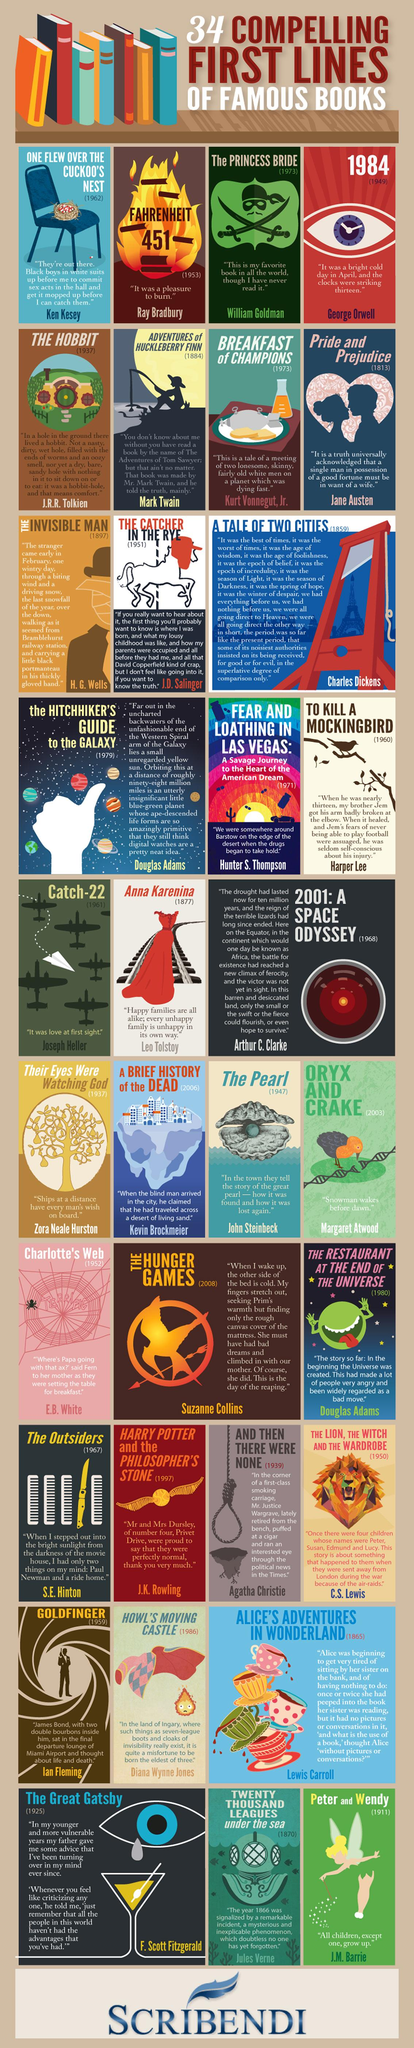Identify some key points in this picture. The author of "Anna Karenina" is Leo Tolstoy. The first line of the book "Catch-22" is "It was love at first sight. The author of the book "Catch-22" is Joseph Heller. The first line of the book "Peter and Wendy" is, 'All children, except one, grow up to realize that it is their parents who make them.' The author of the award-winning novel, 'To Kill a Mockingbird,' is Harper Lee. 